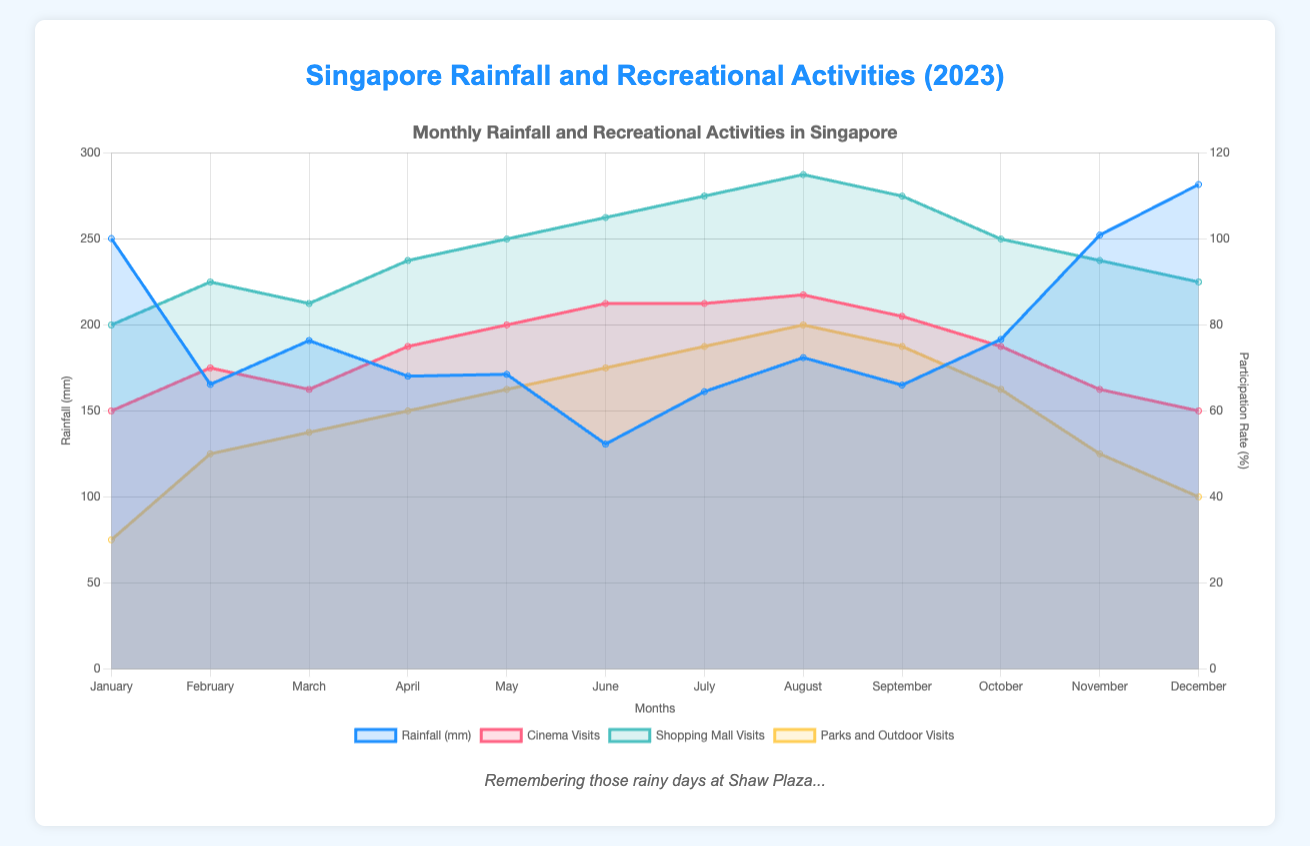What's the title of the figure? The title of the figure can be found at the top, clearly stating the theme of the chart. It reads "Singapore Rainfall and Recreational Activities (2023)."
Answer: Singapore Rainfall and Recreational Activities (2023) How many months have rainfall greater than 200 mm? By examining the line representing rainfall, we can identify the months where the rainfall value crosses the 200 mm mark. These months are January, November, and December.
Answer: 3 Which recreational activity has the highest participation rate in August? By looking at the data points for August, it's clear that "Shopping Mall Visits" reaches the highest participation rate compared to the other activities.
Answer: Shopping Mall Visits What is the color used to represent Cinema visits? The color used to represent Cinema visits can be identified by looking at the legend and seeing which color is associated with Cinema visits. It is represented by a pinkish color (pink background with a pink border).
Answer: Pink During which month is the difference between shopping mall visits and park visits the greatest? To determine this, we need to explore each month's data for both Shopping Mall Visits and Parks and Outdoor Visits. Calculating the difference between these values, the largest difference occurs in August (115 for mall visits - 80 for park visits = 35).
Answer: August What is the average rainfall for the months where cinema visits are above 80%? Cinema visits surpass 80% in June, July, and August. Summing up the rainfall for these months (130.7 mm + 161.2 mm + 181.0 mm = 472.9 mm) and dividing by 3 gives the average.
Answer: 157.63 mm Which month has the lowest participation rate in Parks and Outdoor Visits? By analyzing the points for Parks and Outdoor Visits, the lowest participation rate occurs in January with 30%.
Answer: January Do visits to shopping malls and cinema follow a similar pattern? By observing the trends for both activities, we see that shopping mall visits generally follow a fairly similar pattern to cinema visits, both tend to peak in June to August and drop in months like January and December.
Answer: Yes Is there any month where all three recreational activity participation rates (cinema, shopping malls, and parks) are increasing compared to the previous month? To identify a month where all three activities increased, look for upward trends across the datasets for consecutive months. This happens from March to April.
Answer: April 